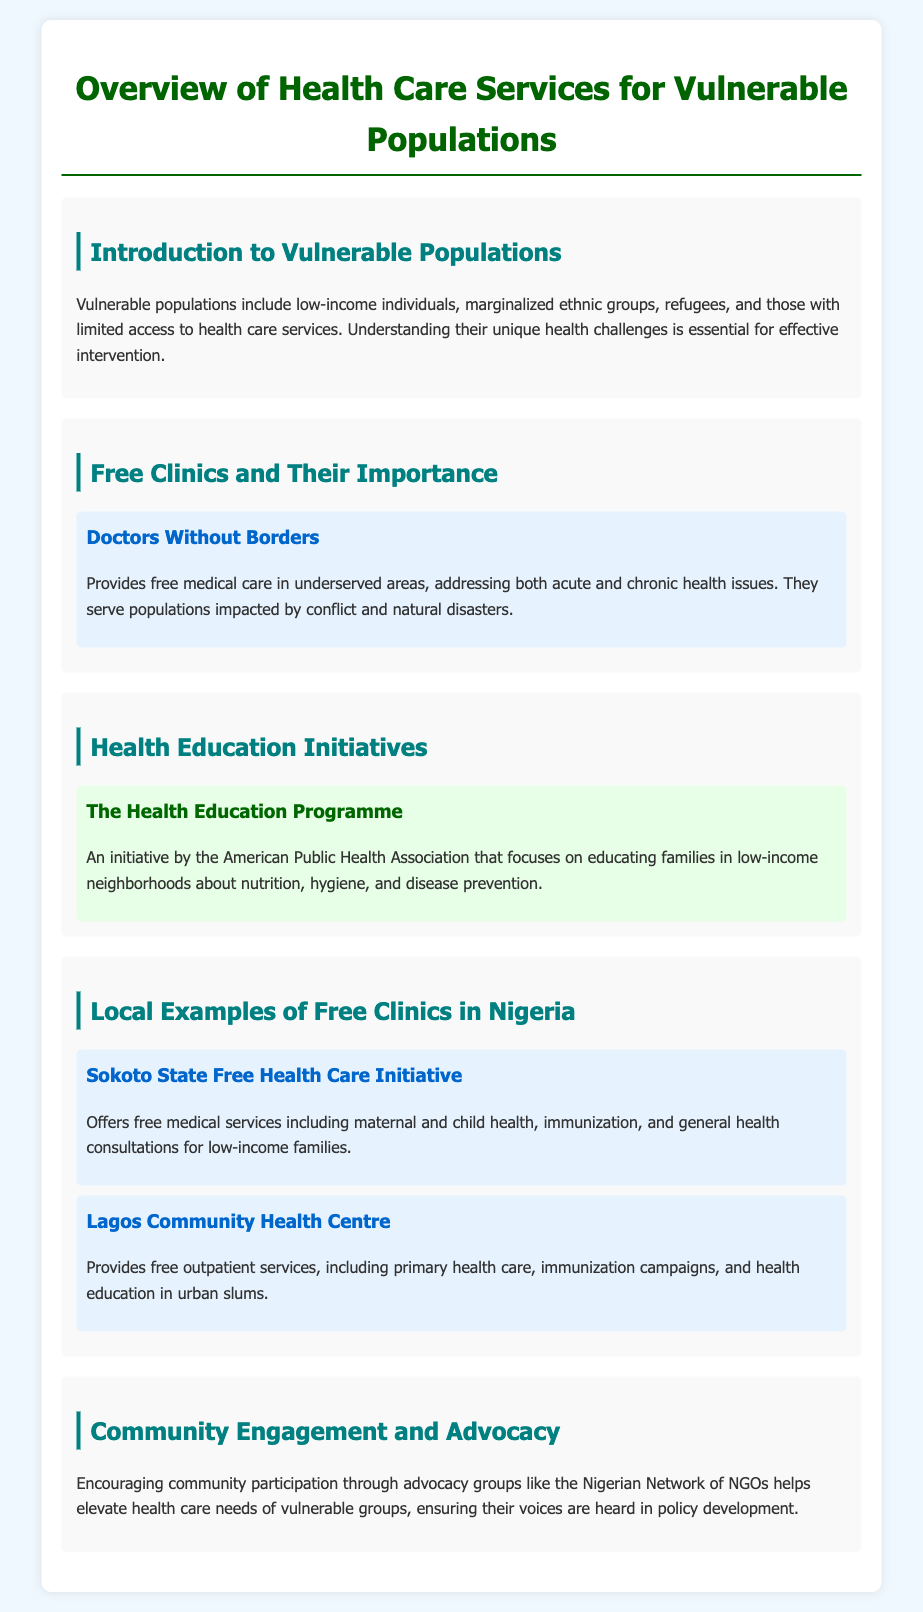What are vulnerable populations? Vulnerable populations include low-income individuals, marginalized ethnic groups, refugees, and those with limited access to health care services.
Answer: Low-income individuals, marginalized ethnic groups, refugees, and those with limited access to health care services What is a free clinic mentioned in the document? A free clinic provides medical care without charge, focusing on underserved populations, such as those impacted by conflict and natural disasters.
Answer: Doctors Without Borders What is the focus of The Health Education Programme? The Health Education Programme focuses on educating families in low-income neighborhoods about nutrition, hygiene, and disease prevention.
Answer: Nutrition, hygiene, and disease prevention How many local free clinics are mentioned in Nigeria? The document lists two specific local free clinics in Nigeria, highlighting their services.
Answer: Two What type of services does Sokoto State Free Health Care Initiative offer? The initiative offers free medical services including maternal and child health, immunization, and general health consultations.
Answer: Maternal and child health, immunization, and general health consultations What role do advocacy groups play for vulnerable populations? Advocacy groups help elevate health care needs of vulnerable groups, ensuring their voices are heard in policy development.
Answer: Elevate health care needs Which community health center offers free outpatient services? The document names a health center that provides primary health care, immunization campaigns, and education in urban slums.
Answer: Lagos Community Health Centre What is an example of community engagement mentioned? The document references the Nigerian Network of NGOs as a way to facilitate community engagement regarding health care needs.
Answer: Nigerian Network of NGOs 